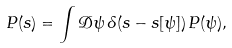<formula> <loc_0><loc_0><loc_500><loc_500>P ( s ) = \int \mathcal { D } \psi \, \delta ( s - s [ \psi ] ) \, P ( \psi ) ,</formula> 